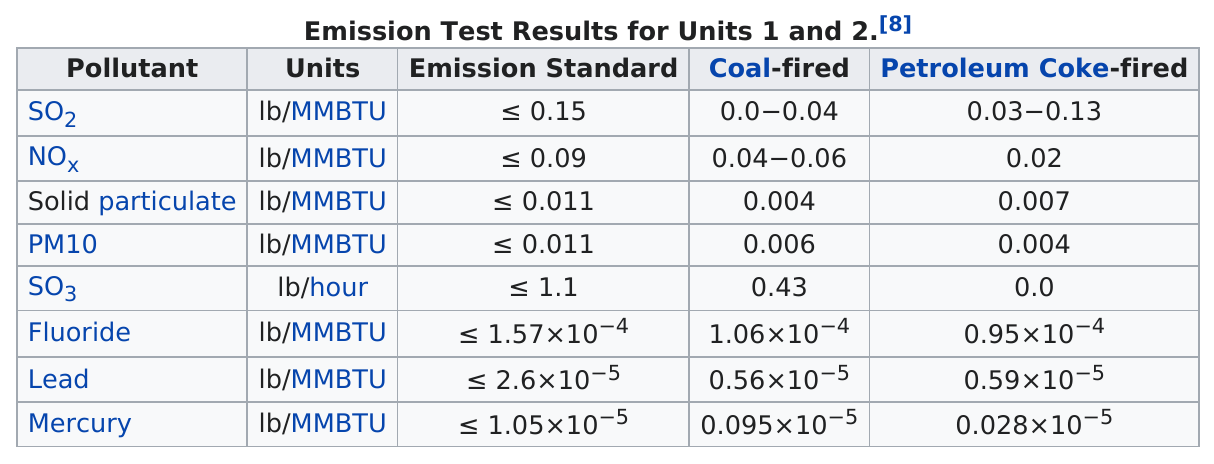Outline some significant characteristics in this image. PM10 and solid particulate matter are both pollutants that have the same emission standard. The pollutants most commonly emitted by facilities that use petcoke as fuel are sulfur dioxide. The pollutant with the least amount of petroleum coke fired is sulfur dioxide (SO2). Each pollutant except SO3 has a common category and unit of measurement. At most 1 emission standard is equal to or less than 1.1. 